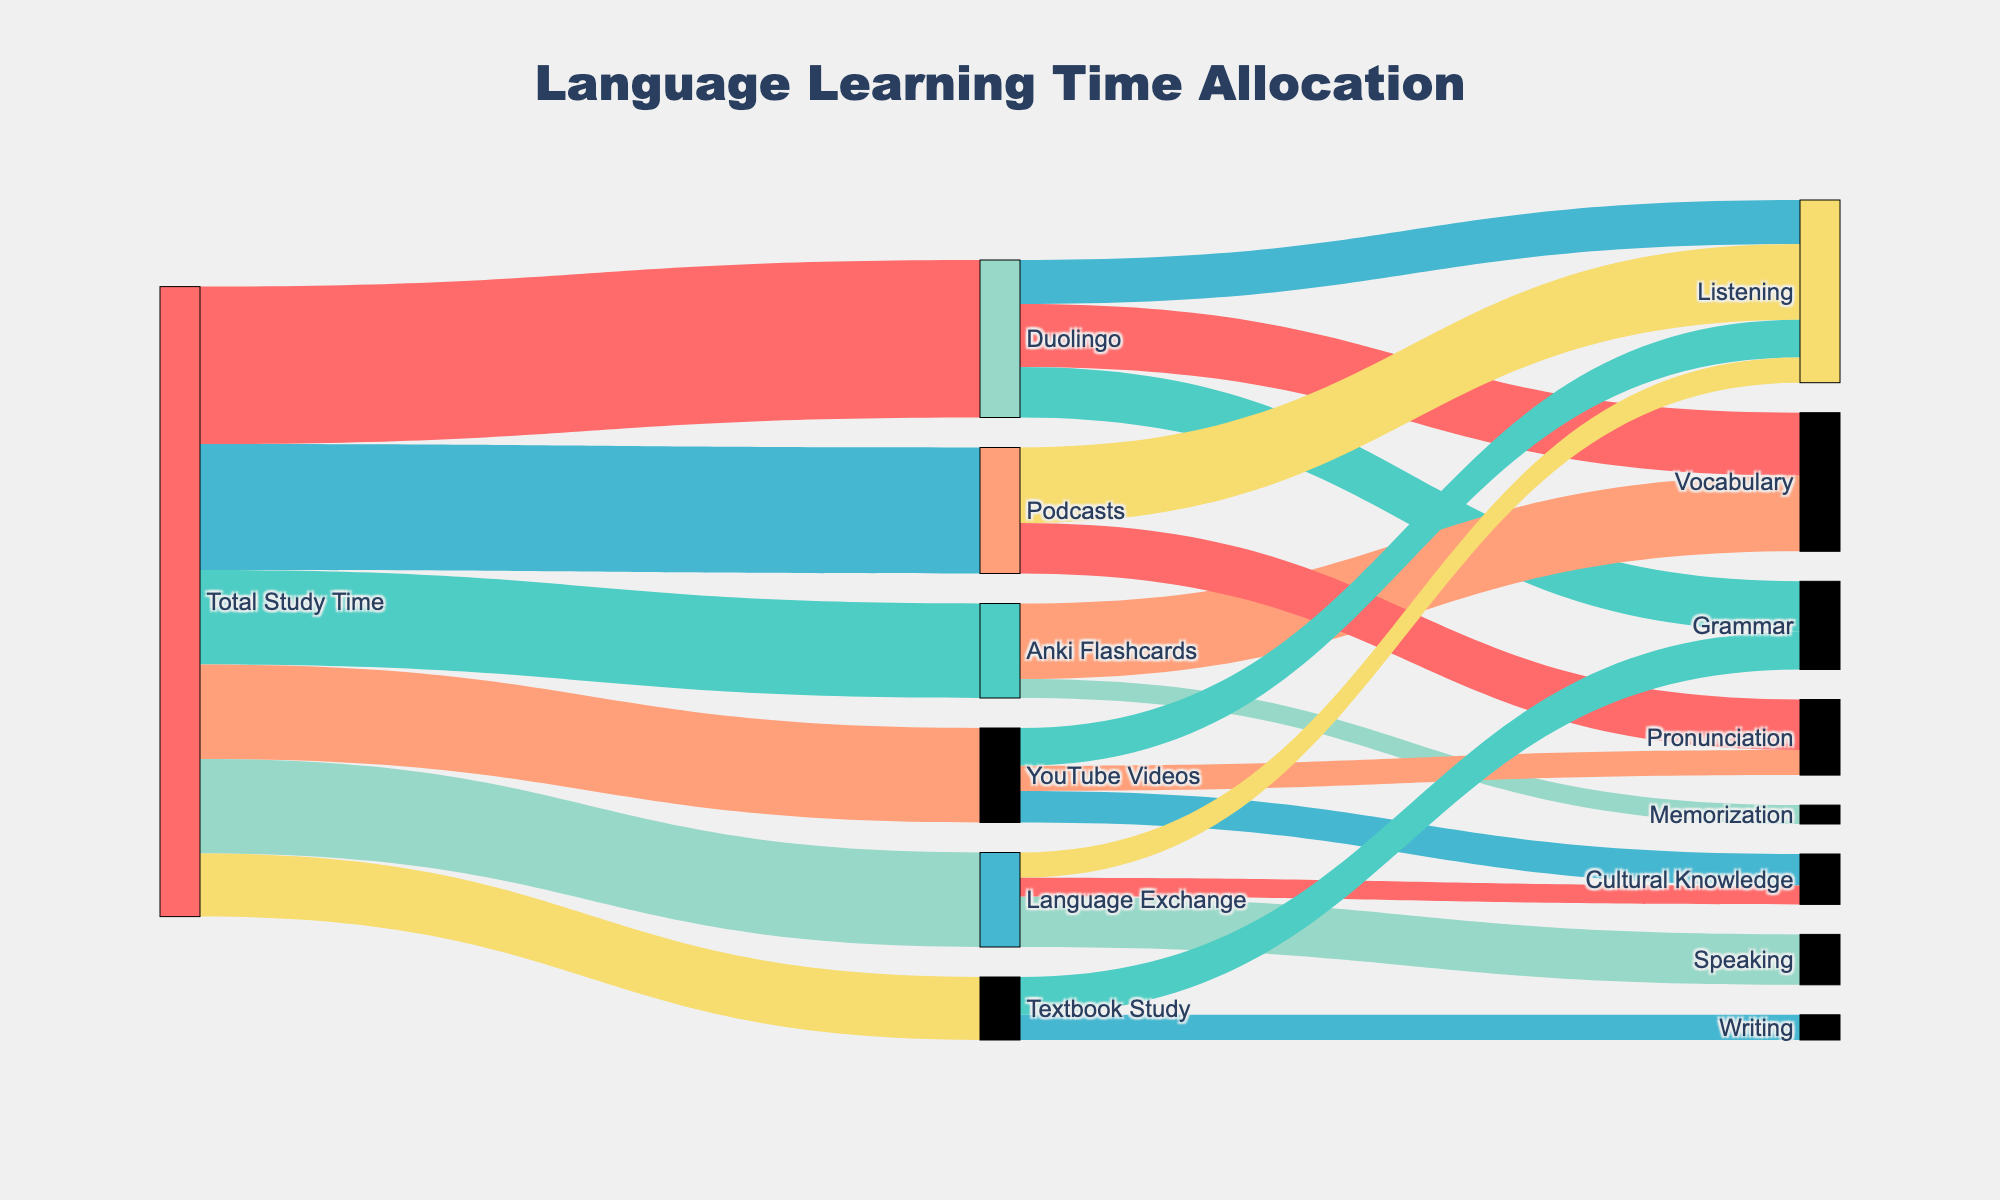what is the total study time allocated to Duolingo? According to the figure, the total study time allocated to Duolingo is represented by the flow from "Total Study Time" to "Duolingo". The value for this flow is 25.
Answer: 25 How much time is spent on grammar study using Duolingo compared to Textbook Study? To find this, look at the flows from "Duolingo" and "Textbook Study" to "Grammar". The value for Duolingo to Grammar is 8, and the value for Textbook Study to Grammar is 6. Comparing these, more time is spent on grammar using Duolingo.
Answer: More time on Duolingo What is the activity that receives the most study time in Language Exchange? Looking at the flows from "Language Exchange" to its activities, the highest value is from Language Exchange to Speaking, which is 8. Therefore, Speaking receives the most study time.
Answer: Speaking Summarize the total time spent on listening activities across all methods. The time spent on listening activities can be found by adding the flows to "Listening" from all methods: Duolingo (7), Podcasts (12), YouTube Videos (6), and Language Exchange (4). Thus, the total time is 7 + 12 + 6 + 4 = 29.
Answer: 29 Which activity receives the least amount of time across all methods? To determine this, find the smallest value among all the flows going to activities. The smallest value is for Anki Flashcards to Memorization, which is 3.
Answer: Memorization Compare the time spent on Vocabulary using Duolingo with the time spent on Memorization using Anki Flashcards. According to the diagram, the flow from Duolingo to Vocabulary is 10, while the flow from Anki Flashcards to Memorization is 3. Vocabulary using Duolingo receives more time.
Answer: Duolingo Vocabulary How much total time is spent on acquiring Cultural Knowledge? To find the total time spent on Cultural Knowledge, sum the values of the flows to Cultural Knowledge: from YouTube Videos (5) and from Language Exchange (3). The total is 5 + 3 = 8.
Answer: 8 Which study method allocates equal time to listening and a different skill? Check the flow values for each method to Listening and compare them with the values for other skills. For Duolingo, 7 minutes are spent on Listening and 8 minutes on Grammar, which is not equal. For Podcasts, 12 on Listening and 8 on Pronunciation, not equal. For YouTube Videos, 6 minutes on Listening and 5 on Cultural Knowledge, not equal. For Language Exchange, 4 on Listening and 4 on Cultural Knowledge, which is equal.
Answer: Language Exchange 